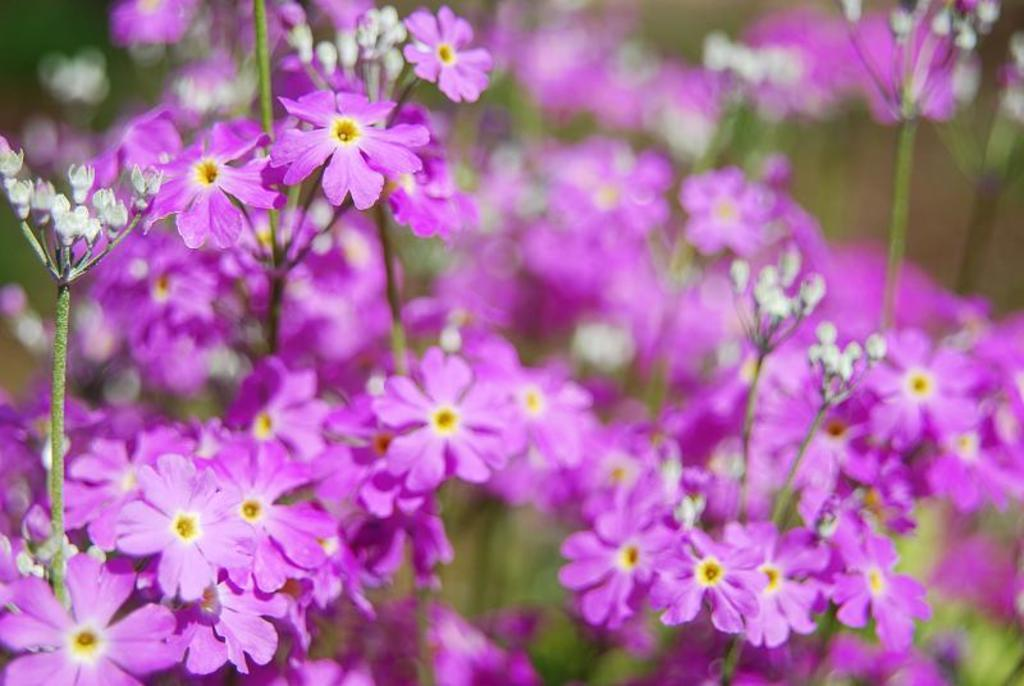What type of plants can be seen in the image? There are flowers in the image. Can you describe the stage of growth for some of the plants? Yes, there are buds in the image. What is the appearance of the background in the image? The background of the image is blurred. How many soldiers are present in the image? There are no soldiers or any reference to an army in the image; it features flowers and buds. 